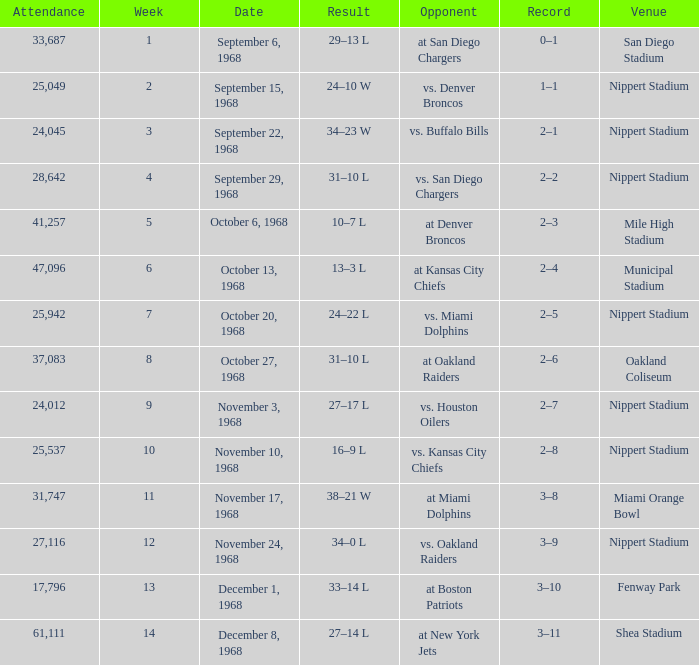What date was the week 6 game played on? October 13, 1968. 